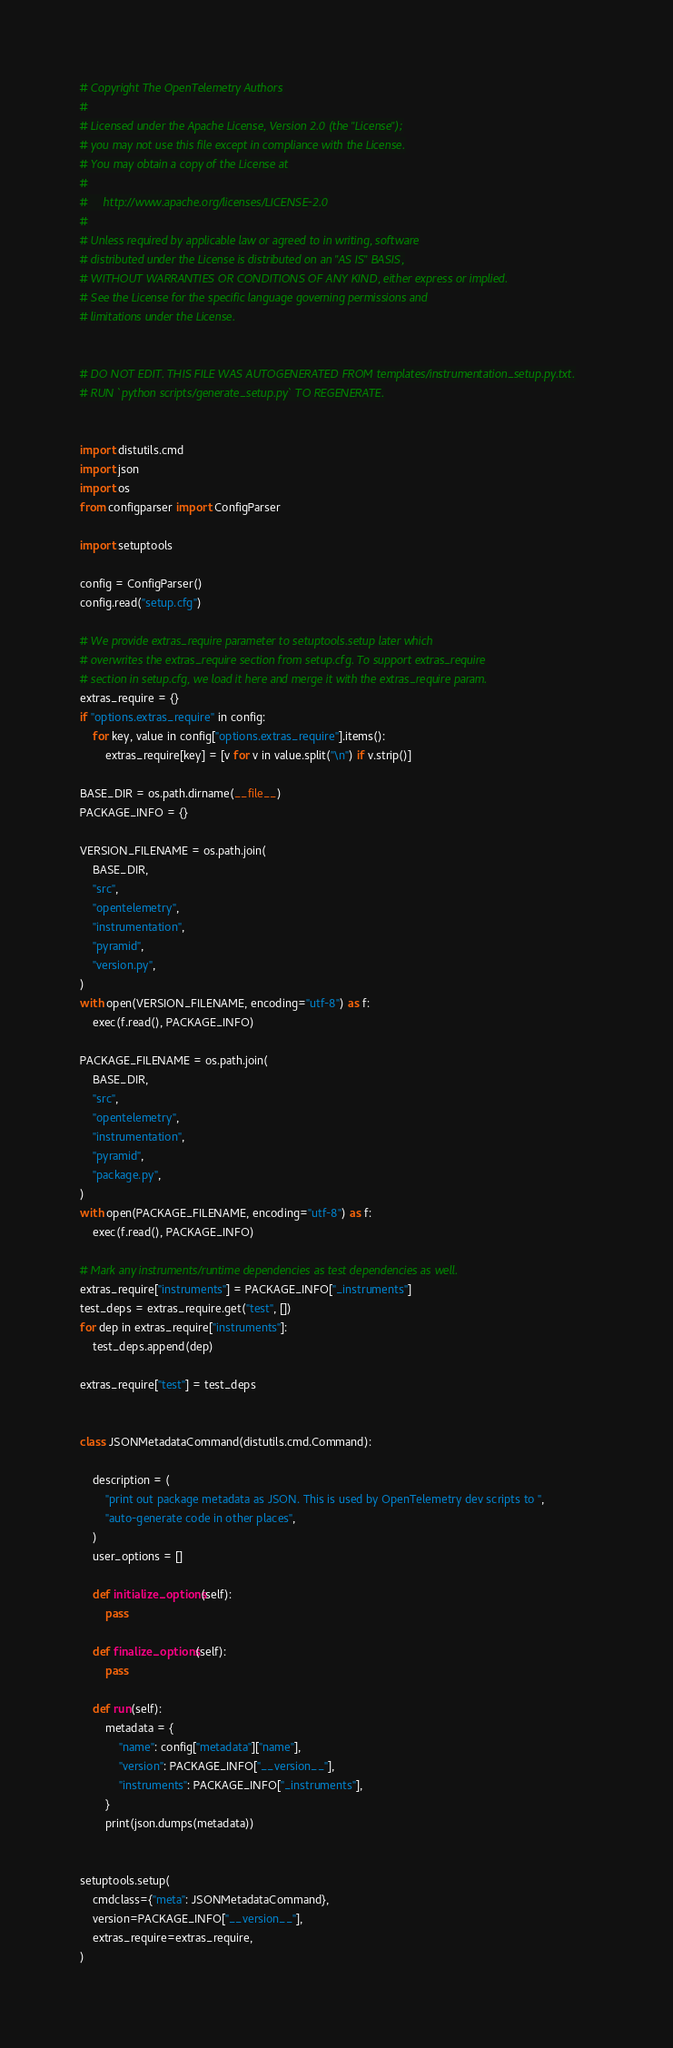Convert code to text. <code><loc_0><loc_0><loc_500><loc_500><_Python_># Copyright The OpenTelemetry Authors
#
# Licensed under the Apache License, Version 2.0 (the "License");
# you may not use this file except in compliance with the License.
# You may obtain a copy of the License at
#
#     http://www.apache.org/licenses/LICENSE-2.0
#
# Unless required by applicable law or agreed to in writing, software
# distributed under the License is distributed on an "AS IS" BASIS,
# WITHOUT WARRANTIES OR CONDITIONS OF ANY KIND, either express or implied.
# See the License for the specific language governing permissions and
# limitations under the License.


# DO NOT EDIT. THIS FILE WAS AUTOGENERATED FROM templates/instrumentation_setup.py.txt.
# RUN `python scripts/generate_setup.py` TO REGENERATE.


import distutils.cmd
import json
import os
from configparser import ConfigParser

import setuptools

config = ConfigParser()
config.read("setup.cfg")

# We provide extras_require parameter to setuptools.setup later which
# overwrites the extras_require section from setup.cfg. To support extras_require
# section in setup.cfg, we load it here and merge it with the extras_require param.
extras_require = {}
if "options.extras_require" in config:
    for key, value in config["options.extras_require"].items():
        extras_require[key] = [v for v in value.split("\n") if v.strip()]

BASE_DIR = os.path.dirname(__file__)
PACKAGE_INFO = {}

VERSION_FILENAME = os.path.join(
    BASE_DIR,
    "src",
    "opentelemetry",
    "instrumentation",
    "pyramid",
    "version.py",
)
with open(VERSION_FILENAME, encoding="utf-8") as f:
    exec(f.read(), PACKAGE_INFO)

PACKAGE_FILENAME = os.path.join(
    BASE_DIR,
    "src",
    "opentelemetry",
    "instrumentation",
    "pyramid",
    "package.py",
)
with open(PACKAGE_FILENAME, encoding="utf-8") as f:
    exec(f.read(), PACKAGE_INFO)

# Mark any instruments/runtime dependencies as test dependencies as well.
extras_require["instruments"] = PACKAGE_INFO["_instruments"]
test_deps = extras_require.get("test", [])
for dep in extras_require["instruments"]:
    test_deps.append(dep)

extras_require["test"] = test_deps


class JSONMetadataCommand(distutils.cmd.Command):

    description = (
        "print out package metadata as JSON. This is used by OpenTelemetry dev scripts to ",
        "auto-generate code in other places",
    )
    user_options = []

    def initialize_options(self):
        pass

    def finalize_options(self):
        pass

    def run(self):
        metadata = {
            "name": config["metadata"]["name"],
            "version": PACKAGE_INFO["__version__"],
            "instruments": PACKAGE_INFO["_instruments"],
        }
        print(json.dumps(metadata))


setuptools.setup(
    cmdclass={"meta": JSONMetadataCommand},
    version=PACKAGE_INFO["__version__"],
    extras_require=extras_require,
)
</code> 